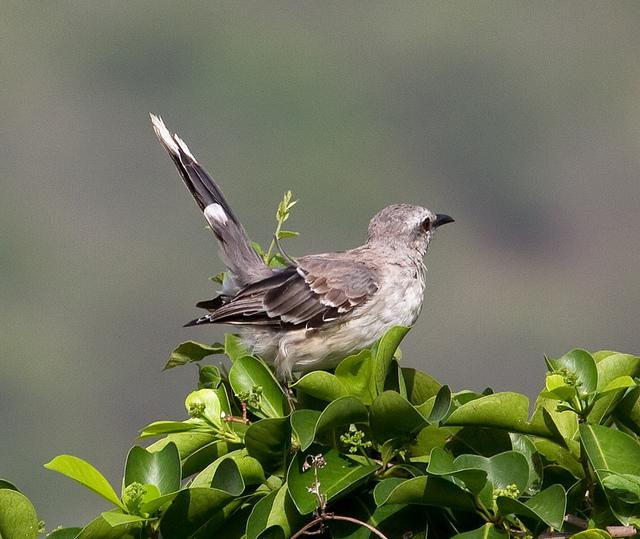What is the bird eating?
Concise answer only. Nothing. What kind of plant is the bird sitting on?
Answer briefly. Tree. Is the bird sitting on a fence?
Be succinct. No. Is the bird relaxing in a nest?
Give a very brief answer. No. How many birds?
Give a very brief answer. 1. Is the bird in this picture singing?
Concise answer only. No. How is this bird able to perch on the  branch?
Quick response, please. Balance. What color is the bird's breast?
Concise answer only. White. What is the bird sitting on?
Quick response, please. Bush. What color is the bird?
Keep it brief. Gray. 